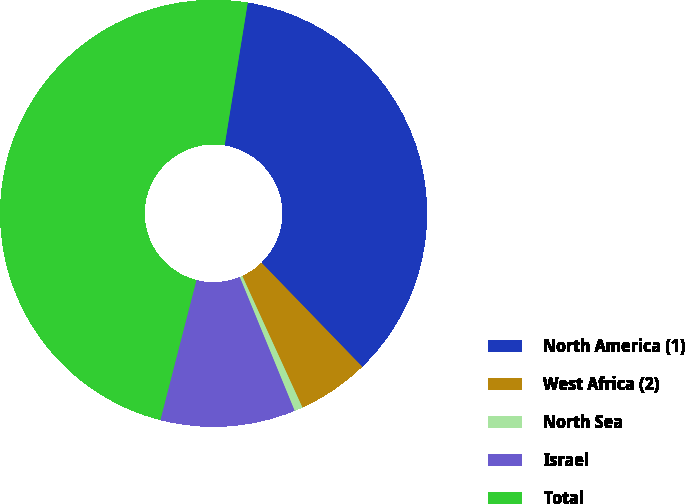<chart> <loc_0><loc_0><loc_500><loc_500><pie_chart><fcel>North America (1)<fcel>West Africa (2)<fcel>North Sea<fcel>Israel<fcel>Total<nl><fcel>35.19%<fcel>5.42%<fcel>0.63%<fcel>10.21%<fcel>48.53%<nl></chart> 